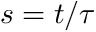<formula> <loc_0><loc_0><loc_500><loc_500>s = t / \tau</formula> 